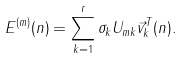<formula> <loc_0><loc_0><loc_500><loc_500>E ^ { ( m ) } ( n ) = \sum _ { k = 1 } ^ { r } \sigma _ { k } U _ { m k } \vec { v } ^ { T } _ { k } ( n ) .</formula> 